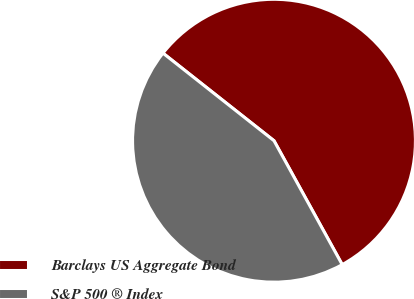Convert chart to OTSL. <chart><loc_0><loc_0><loc_500><loc_500><pie_chart><fcel>Barclays US Aggregate Bond<fcel>S&P 500 ® Index<nl><fcel>56.36%<fcel>43.64%<nl></chart> 